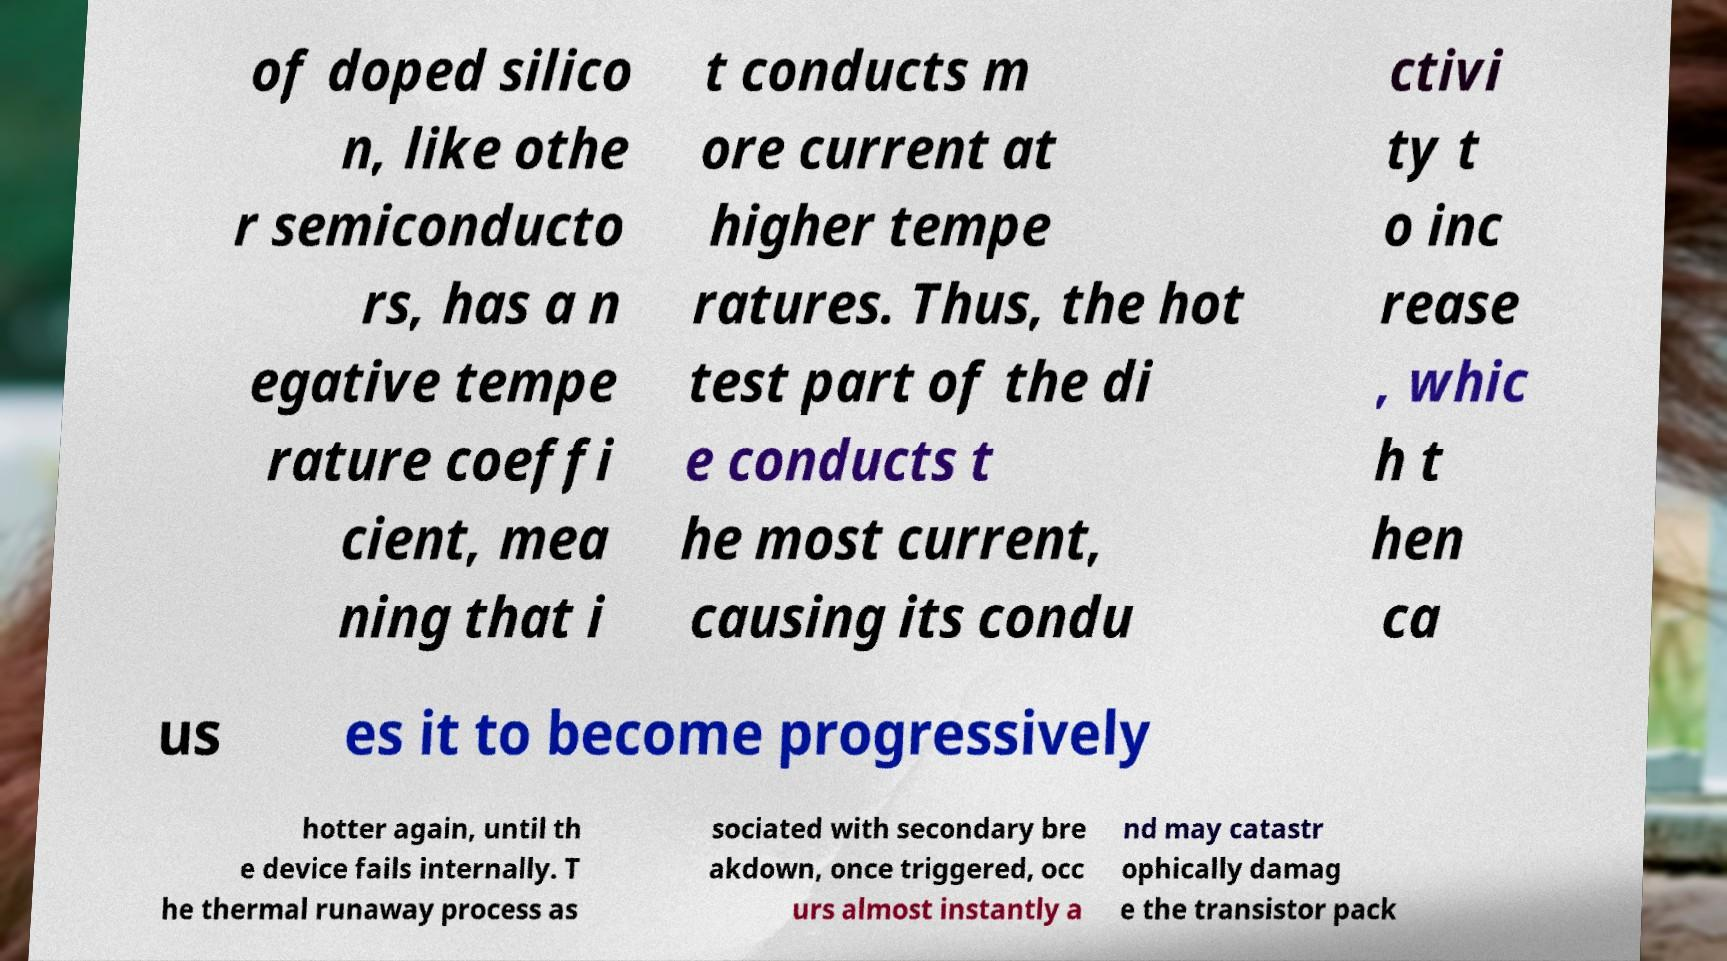Can you accurately transcribe the text from the provided image for me? of doped silico n, like othe r semiconducto rs, has a n egative tempe rature coeffi cient, mea ning that i t conducts m ore current at higher tempe ratures. Thus, the hot test part of the di e conducts t he most current, causing its condu ctivi ty t o inc rease , whic h t hen ca us es it to become progressively hotter again, until th e device fails internally. T he thermal runaway process as sociated with secondary bre akdown, once triggered, occ urs almost instantly a nd may catastr ophically damag e the transistor pack 